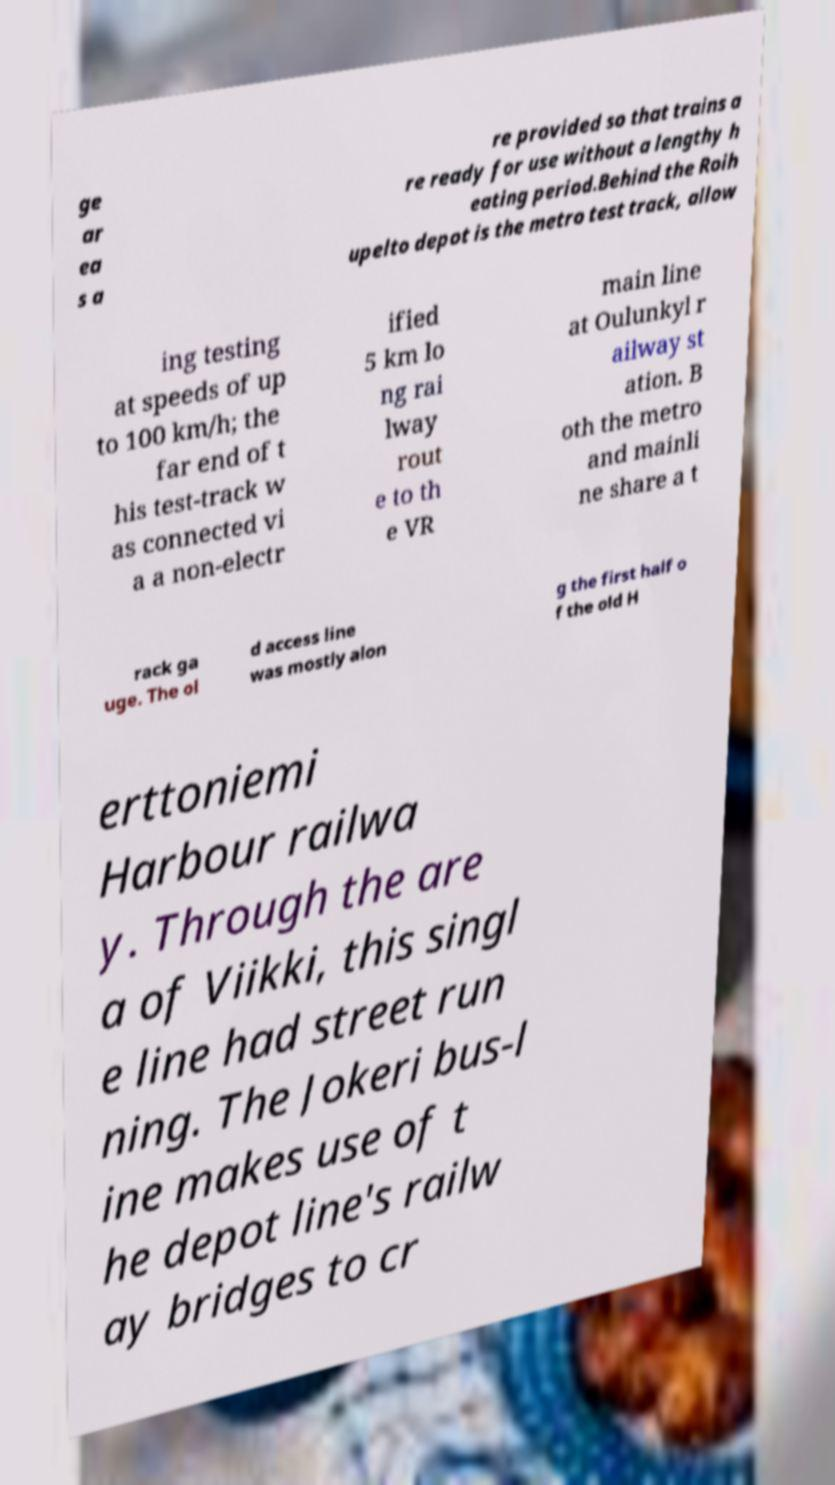Could you assist in decoding the text presented in this image and type it out clearly? ge ar ea s a re provided so that trains a re ready for use without a lengthy h eating period.Behind the Roih upelto depot is the metro test track, allow ing testing at speeds of up to 100 km/h; the far end of t his test-track w as connected vi a a non-electr ified 5 km lo ng rai lway rout e to th e VR main line at Oulunkyl r ailway st ation. B oth the metro and mainli ne share a t rack ga uge. The ol d access line was mostly alon g the first half o f the old H erttoniemi Harbour railwa y. Through the are a of Viikki, this singl e line had street run ning. The Jokeri bus-l ine makes use of t he depot line's railw ay bridges to cr 